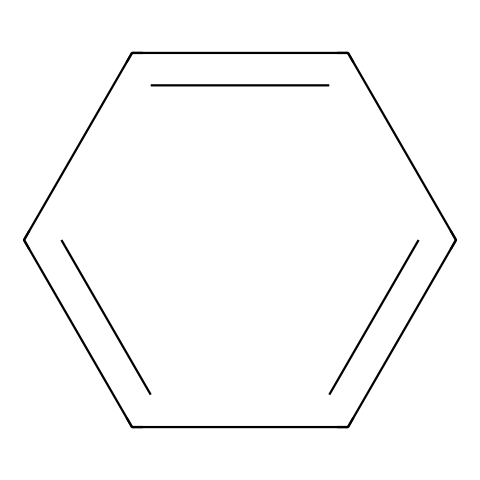what is the name of this chemical? The SMILES representation c1ccccc1 denotes the structure of benzene, which is a well-known aromatic compound. Benzene is characterized by its hexagonal ring structure with alternating double bonds.
Answer: benzene how many carbon atoms are in the structure? The SMILES c1ccccc1 indicates a six-membered ring made up entirely of carbon atoms, as each letter 'c' represents a carbon atom. Thus, there are six carbon atoms in total.
Answer: six how many hydrogen atoms are bonded to this structure? In benzene, each carbon atom is bonded to one hydrogen atom due to its tetravalent nature. Since there are six carbon atoms in the ring, the total number of hydrogen atoms bonded is six.
Answer: six what type of hybridization do the carbon atoms in this structure exhibit? The carbon atoms in benzene are involved in sp2 hybridization, as they form a planar structure with bond angles of approximately 120 degrees, which is characteristic of aromatic compounds.
Answer: sp2 what kind of intermolecular forces are present between benzene molecules? Benzene molecules primarily exhibit London dispersion forces (or van der Waals forces) due to their non-polar character and symmetric shape, making them weak but significant in the liquid state.
Answer: London dispersion forces why does benzene have a distinctive sweet smell in beverages? Benzene derivatives can contribute to the sweet smell in beverages due to the resonance stabilization of the ring structure, which allows for a variety of flavorful substitution patterns and aromatic characteristics.
Answer: resonance stabilization 